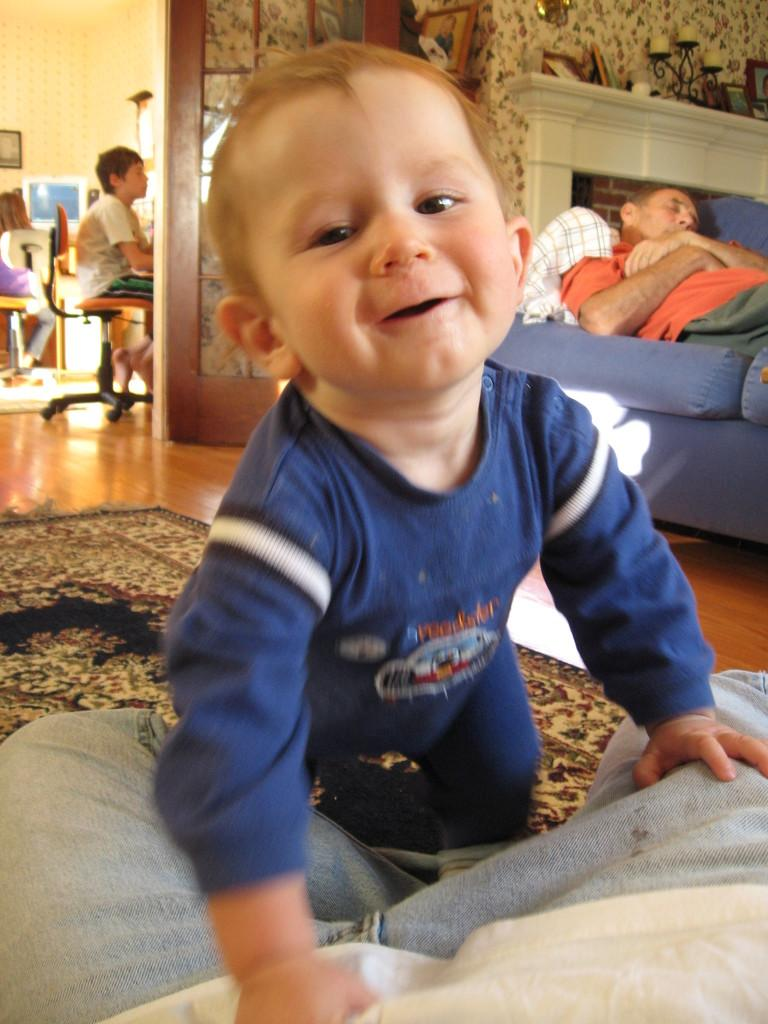Who is the main subject in the image? There is a boy in the image. What is the boy wearing? The boy is wearing a blue dress. What expression does the boy have? The boy has a smile on his face. Can you describe the man in the background of the image? The man is lying on a sofa in the background. Are there any other children in the image? Yes, there is another boy in the background of the image. What is the boy in the background doing? The boy in the background is sitting on a chair. What type of property is being sold in the image? There is no indication of any property being sold in the image. What form of currency is being used to purchase items in the image? There is no indication of any currency or purchase in the image. 